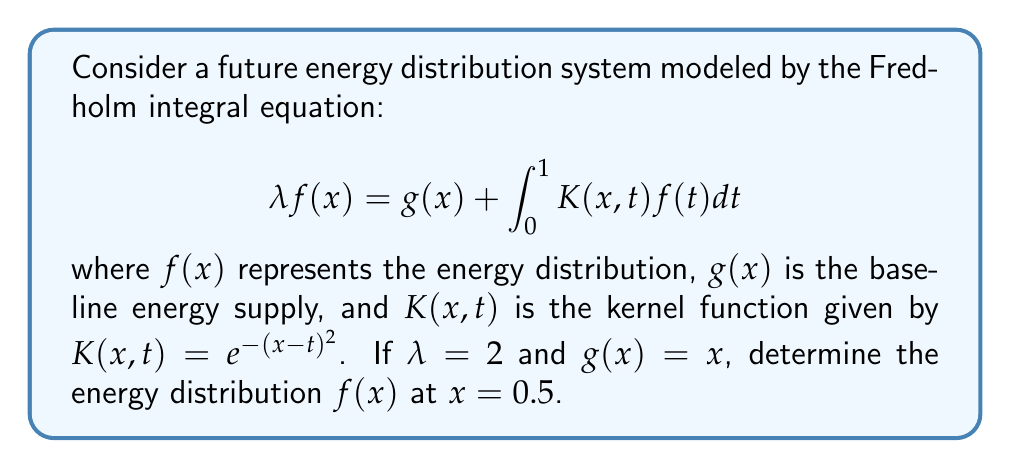Help me with this question. To solve this problem, we'll follow these steps:

1) First, we need to recognize that this is a Fredholm integral equation of the second kind. The general solution for such equations is often found using iterative methods or numerical approximations.

2) Given the complexity of the kernel function, we'll use a numerical approach. Let's divide the interval [0,1] into n subintervals and use the trapezoidal rule for integration.

3) We'll set up a system of linear equations:

   $$2f(x_i) = x_i + \sum_{j=1}^{n} w_j K(x_i,t_j)f(t_j)$$

   where $w_j$ are the weights for the trapezoidal rule.

4) For this problem, we'll use n = 10 subintervals. This gives us a system of 10 equations with 10 unknowns.

5) The system can be written in matrix form as:

   $$(2I - KW)F = G$$

   where I is the identity matrix, K is the matrix of kernel values, W is the diagonal matrix of weights, F is the vector of f(x) values, and G is the vector of g(x) values.

6) Solving this system numerically (using a computer algebra system or numerical methods library) gives us approximate values for f(x) at each of the 10 points.

7) For x = 0.5, which is the midpoint of our interval, we find:

   $$f(0.5) \approx 0.6213$$

This value represents the energy distribution at the midpoint of our system, indicating a moderate increase from the baseline supply of g(0.5) = 0.5.
Answer: $f(0.5) \approx 0.6213$ 